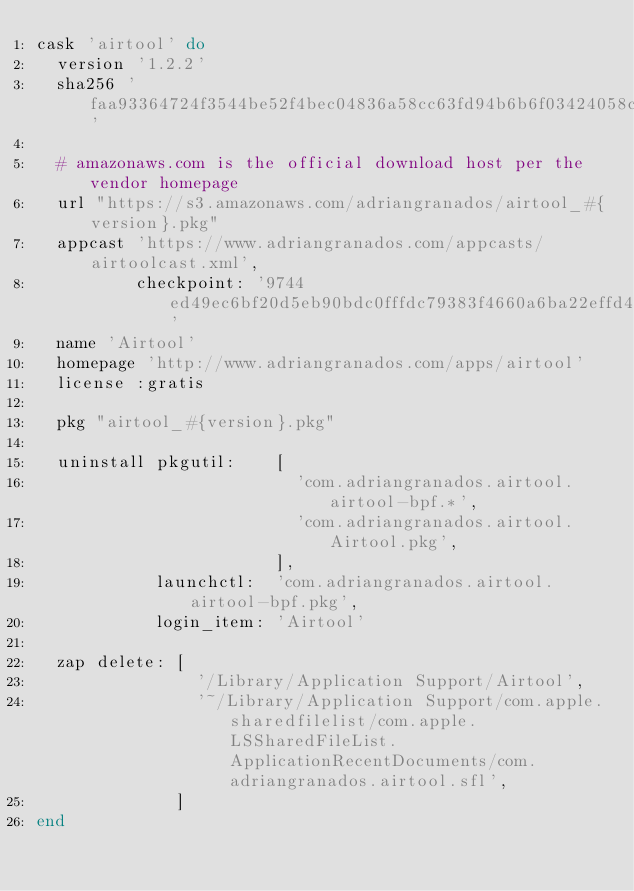<code> <loc_0><loc_0><loc_500><loc_500><_Ruby_>cask 'airtool' do
  version '1.2.2'
  sha256 'faa93364724f3544be52f4bec04836a58cc63fd94b6b6f03424058c4e61ee076'

  # amazonaws.com is the official download host per the vendor homepage
  url "https://s3.amazonaws.com/adriangranados/airtool_#{version}.pkg"
  appcast 'https://www.adriangranados.com/appcasts/airtoolcast.xml',
          checkpoint: '9744ed49ec6bf20d5eb90bdc0fffdc79383f4660a6ba22effd4399b5297feb36'
  name 'Airtool'
  homepage 'http://www.adriangranados.com/apps/airtool'
  license :gratis

  pkg "airtool_#{version}.pkg"

  uninstall pkgutil:    [
                          'com.adriangranados.airtool.airtool-bpf.*',
                          'com.adriangranados.airtool.Airtool.pkg',
                        ],
            launchctl:  'com.adriangranados.airtool.airtool-bpf.pkg',
            login_item: 'Airtool'

  zap delete: [
                '/Library/Application Support/Airtool',
                '~/Library/Application Support/com.apple.sharedfilelist/com.apple.LSSharedFileList.ApplicationRecentDocuments/com.adriangranados.airtool.sfl',
              ]
end
</code> 